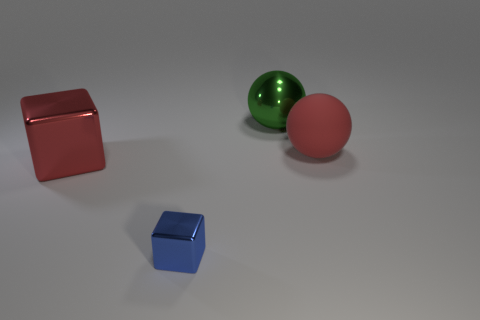What is the color of the tiny cube that is made of the same material as the big red cube?
Ensure brevity in your answer.  Blue. There is a small thing; does it have the same shape as the large red object to the left of the small blue metal cube?
Your answer should be compact. Yes. Are there any red blocks on the right side of the shiny sphere?
Offer a terse response. No. There is another object that is the same color as the large matte thing; what material is it?
Offer a terse response. Metal. There is a red shiny thing; does it have the same size as the cube in front of the large cube?
Give a very brief answer. No. Are there any other big balls of the same color as the rubber ball?
Ensure brevity in your answer.  No. Is there a tiny metal object of the same shape as the big red rubber object?
Your answer should be compact. No. The thing that is both on the left side of the large red sphere and to the right of the tiny blue shiny block has what shape?
Offer a very short reply. Sphere. What number of other blue things are the same material as the blue thing?
Keep it short and to the point. 0. Are there fewer red metal things that are right of the big rubber ball than large rubber objects?
Ensure brevity in your answer.  Yes. 